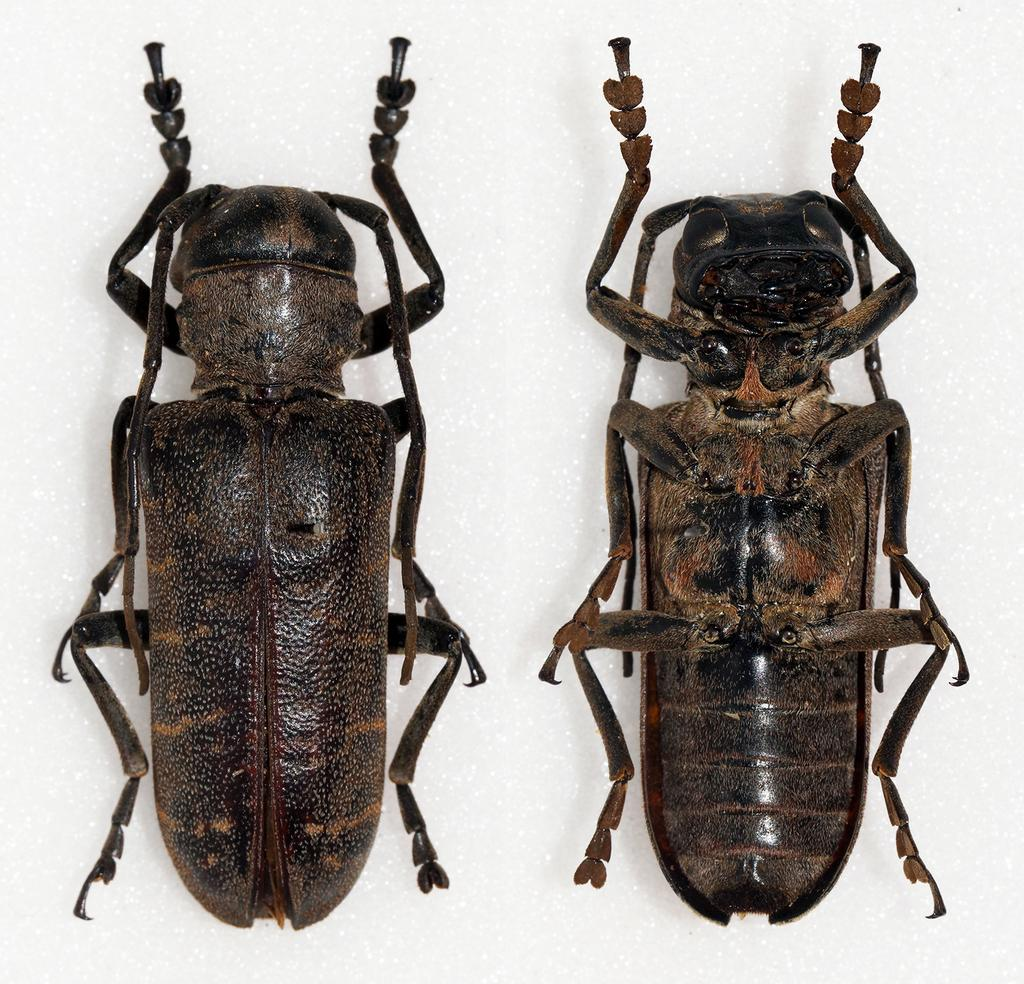What is the main subject of the image? The main subject of the image is two dead cockroaches. Where are the cockroaches located in the image? The cockroaches are in the center of the image. How many rabbits can be seen playing with rice in the image? There are no rabbits or rice present in the image; it features two dead cockroaches. 